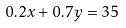<formula> <loc_0><loc_0><loc_500><loc_500>0 . 2 x + 0 . 7 y = 3 5</formula> 